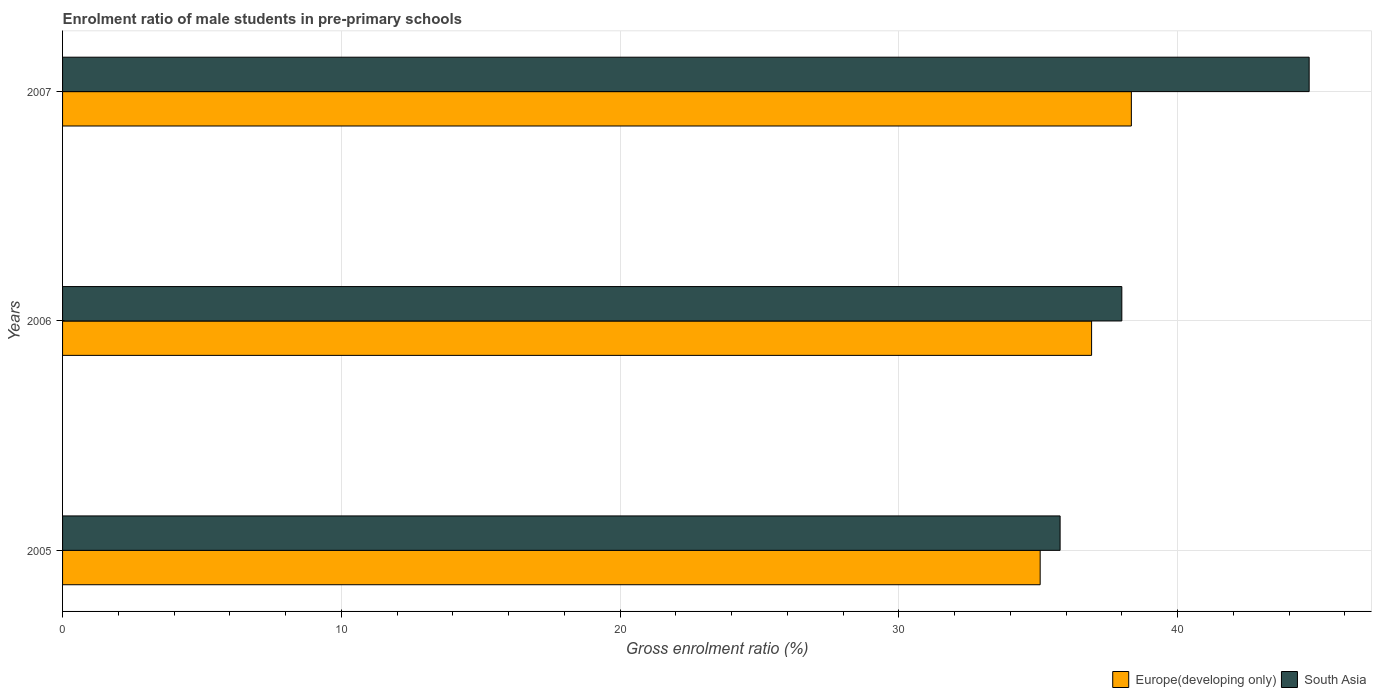Are the number of bars on each tick of the Y-axis equal?
Give a very brief answer. Yes. How many bars are there on the 3rd tick from the bottom?
Ensure brevity in your answer.  2. In how many cases, is the number of bars for a given year not equal to the number of legend labels?
Offer a very short reply. 0. What is the enrolment ratio of male students in pre-primary schools in South Asia in 2007?
Provide a short and direct response. 44.72. Across all years, what is the maximum enrolment ratio of male students in pre-primary schools in Europe(developing only)?
Keep it short and to the point. 38.34. Across all years, what is the minimum enrolment ratio of male students in pre-primary schools in Europe(developing only)?
Your answer should be very brief. 35.07. In which year was the enrolment ratio of male students in pre-primary schools in Europe(developing only) maximum?
Your response must be concise. 2007. In which year was the enrolment ratio of male students in pre-primary schools in South Asia minimum?
Your answer should be compact. 2005. What is the total enrolment ratio of male students in pre-primary schools in Europe(developing only) in the graph?
Give a very brief answer. 110.32. What is the difference between the enrolment ratio of male students in pre-primary schools in South Asia in 2005 and that in 2006?
Make the answer very short. -2.21. What is the difference between the enrolment ratio of male students in pre-primary schools in South Asia in 2005 and the enrolment ratio of male students in pre-primary schools in Europe(developing only) in 2007?
Offer a very short reply. -2.56. What is the average enrolment ratio of male students in pre-primary schools in South Asia per year?
Ensure brevity in your answer.  39.5. In the year 2007, what is the difference between the enrolment ratio of male students in pre-primary schools in South Asia and enrolment ratio of male students in pre-primary schools in Europe(developing only)?
Ensure brevity in your answer.  6.38. What is the ratio of the enrolment ratio of male students in pre-primary schools in Europe(developing only) in 2005 to that in 2006?
Provide a succinct answer. 0.95. Is the enrolment ratio of male students in pre-primary schools in Europe(developing only) in 2006 less than that in 2007?
Offer a terse response. Yes. Is the difference between the enrolment ratio of male students in pre-primary schools in South Asia in 2005 and 2007 greater than the difference between the enrolment ratio of male students in pre-primary schools in Europe(developing only) in 2005 and 2007?
Make the answer very short. No. What is the difference between the highest and the second highest enrolment ratio of male students in pre-primary schools in Europe(developing only)?
Provide a succinct answer. 1.43. What is the difference between the highest and the lowest enrolment ratio of male students in pre-primary schools in Europe(developing only)?
Ensure brevity in your answer.  3.27. Is the sum of the enrolment ratio of male students in pre-primary schools in Europe(developing only) in 2006 and 2007 greater than the maximum enrolment ratio of male students in pre-primary schools in South Asia across all years?
Make the answer very short. Yes. What does the 1st bar from the top in 2007 represents?
Provide a succinct answer. South Asia. What does the 1st bar from the bottom in 2006 represents?
Make the answer very short. Europe(developing only). How many bars are there?
Give a very brief answer. 6. Are all the bars in the graph horizontal?
Offer a very short reply. Yes. How many years are there in the graph?
Give a very brief answer. 3. What is the difference between two consecutive major ticks on the X-axis?
Offer a terse response. 10. Does the graph contain any zero values?
Give a very brief answer. No. What is the title of the graph?
Keep it short and to the point. Enrolment ratio of male students in pre-primary schools. Does "Marshall Islands" appear as one of the legend labels in the graph?
Provide a succinct answer. No. What is the label or title of the Y-axis?
Your answer should be compact. Years. What is the Gross enrolment ratio (%) of Europe(developing only) in 2005?
Offer a very short reply. 35.07. What is the Gross enrolment ratio (%) of South Asia in 2005?
Offer a very short reply. 35.78. What is the Gross enrolment ratio (%) of Europe(developing only) in 2006?
Offer a very short reply. 36.91. What is the Gross enrolment ratio (%) in South Asia in 2006?
Your answer should be very brief. 38. What is the Gross enrolment ratio (%) of Europe(developing only) in 2007?
Offer a very short reply. 38.34. What is the Gross enrolment ratio (%) in South Asia in 2007?
Provide a short and direct response. 44.72. Across all years, what is the maximum Gross enrolment ratio (%) in Europe(developing only)?
Provide a short and direct response. 38.34. Across all years, what is the maximum Gross enrolment ratio (%) in South Asia?
Keep it short and to the point. 44.72. Across all years, what is the minimum Gross enrolment ratio (%) of Europe(developing only)?
Ensure brevity in your answer.  35.07. Across all years, what is the minimum Gross enrolment ratio (%) of South Asia?
Ensure brevity in your answer.  35.78. What is the total Gross enrolment ratio (%) in Europe(developing only) in the graph?
Offer a very short reply. 110.32. What is the total Gross enrolment ratio (%) in South Asia in the graph?
Offer a very short reply. 118.5. What is the difference between the Gross enrolment ratio (%) of Europe(developing only) in 2005 and that in 2006?
Your answer should be very brief. -1.84. What is the difference between the Gross enrolment ratio (%) of South Asia in 2005 and that in 2006?
Your answer should be compact. -2.21. What is the difference between the Gross enrolment ratio (%) of Europe(developing only) in 2005 and that in 2007?
Offer a terse response. -3.27. What is the difference between the Gross enrolment ratio (%) in South Asia in 2005 and that in 2007?
Make the answer very short. -8.93. What is the difference between the Gross enrolment ratio (%) in Europe(developing only) in 2006 and that in 2007?
Ensure brevity in your answer.  -1.43. What is the difference between the Gross enrolment ratio (%) in South Asia in 2006 and that in 2007?
Keep it short and to the point. -6.72. What is the difference between the Gross enrolment ratio (%) in Europe(developing only) in 2005 and the Gross enrolment ratio (%) in South Asia in 2006?
Provide a succinct answer. -2.93. What is the difference between the Gross enrolment ratio (%) of Europe(developing only) in 2005 and the Gross enrolment ratio (%) of South Asia in 2007?
Your answer should be very brief. -9.65. What is the difference between the Gross enrolment ratio (%) in Europe(developing only) in 2006 and the Gross enrolment ratio (%) in South Asia in 2007?
Your response must be concise. -7.8. What is the average Gross enrolment ratio (%) in Europe(developing only) per year?
Offer a terse response. 36.77. What is the average Gross enrolment ratio (%) in South Asia per year?
Offer a terse response. 39.5. In the year 2005, what is the difference between the Gross enrolment ratio (%) of Europe(developing only) and Gross enrolment ratio (%) of South Asia?
Give a very brief answer. -0.72. In the year 2006, what is the difference between the Gross enrolment ratio (%) of Europe(developing only) and Gross enrolment ratio (%) of South Asia?
Offer a very short reply. -1.08. In the year 2007, what is the difference between the Gross enrolment ratio (%) of Europe(developing only) and Gross enrolment ratio (%) of South Asia?
Your answer should be very brief. -6.38. What is the ratio of the Gross enrolment ratio (%) of Europe(developing only) in 2005 to that in 2006?
Give a very brief answer. 0.95. What is the ratio of the Gross enrolment ratio (%) in South Asia in 2005 to that in 2006?
Provide a succinct answer. 0.94. What is the ratio of the Gross enrolment ratio (%) in Europe(developing only) in 2005 to that in 2007?
Make the answer very short. 0.91. What is the ratio of the Gross enrolment ratio (%) in South Asia in 2005 to that in 2007?
Provide a short and direct response. 0.8. What is the ratio of the Gross enrolment ratio (%) in Europe(developing only) in 2006 to that in 2007?
Provide a short and direct response. 0.96. What is the ratio of the Gross enrolment ratio (%) of South Asia in 2006 to that in 2007?
Offer a very short reply. 0.85. What is the difference between the highest and the second highest Gross enrolment ratio (%) of Europe(developing only)?
Keep it short and to the point. 1.43. What is the difference between the highest and the second highest Gross enrolment ratio (%) in South Asia?
Make the answer very short. 6.72. What is the difference between the highest and the lowest Gross enrolment ratio (%) in Europe(developing only)?
Give a very brief answer. 3.27. What is the difference between the highest and the lowest Gross enrolment ratio (%) of South Asia?
Make the answer very short. 8.93. 